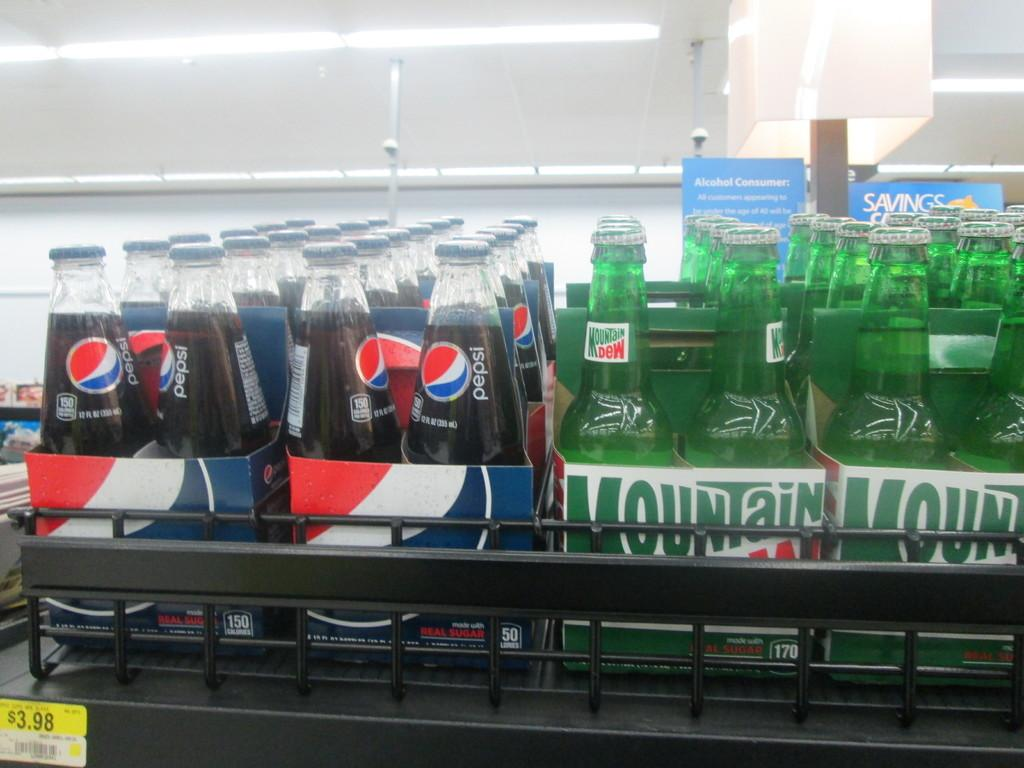<image>
Share a concise interpretation of the image provided. Mountain dew is next to the pepsi in the fridge 